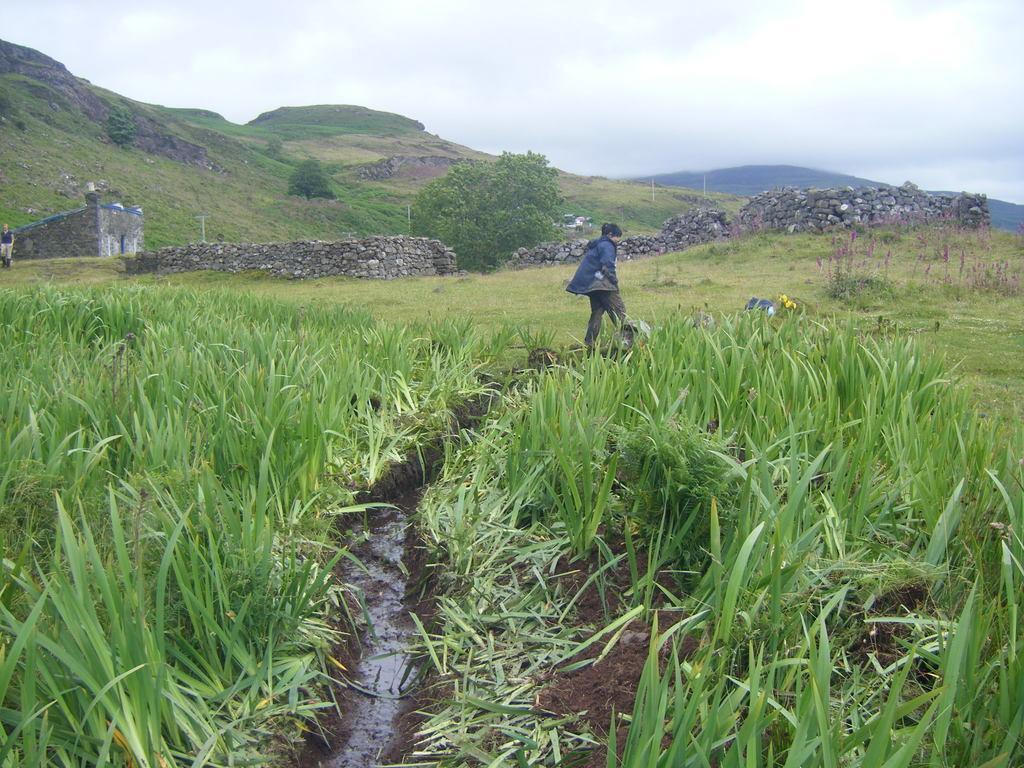Describe this image in one or two sentences. In this picture we can see a person walking on the path. Some grass is visible on the right and left side. There is a path. We can see a house and a human on the left side. Sky is cloudy. 